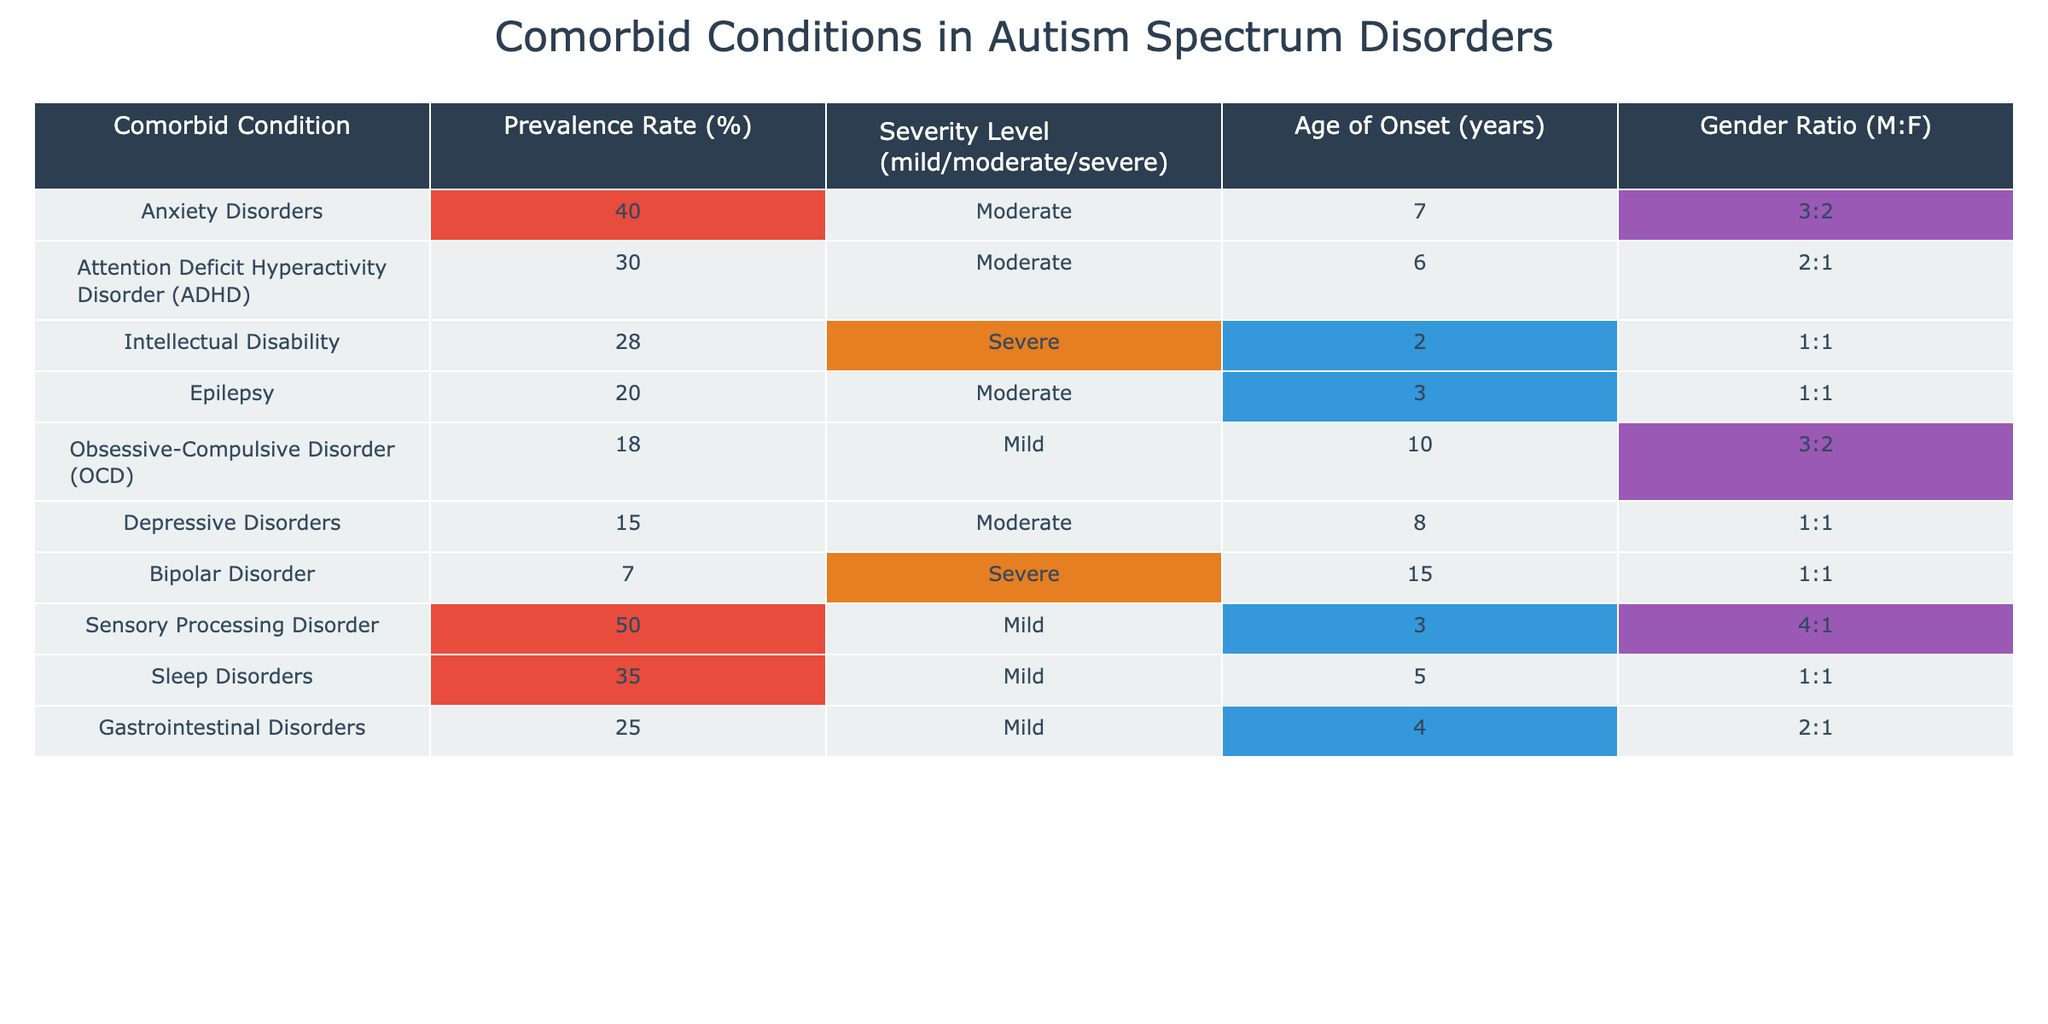What is the prevalence rate of Anxiety Disorders among individuals diagnosed with autism spectrum disorders? The table shows that the prevalence rate for Anxiety Disorders is 40%.
Answer: 40% Which comorbid condition has the highest prevalence rate? Looking at the table, Sensory Processing Disorder has a prevalence rate of 50%, which is the highest among all listed conditions.
Answer: Sensory Processing Disorder What is the age of onset for Intellectual Disability? The table states that the age of onset for Intellectual Disability is 2 years.
Answer: 2 years How many conditions listed have a severity level classified as 'Severe'? According to the table, there are 2 conditions classified as 'Severe': Intellectual Disability and Bipolar Disorder.
Answer: 2 Is the prevalence rate of Sleep Disorders higher than that of Depressive Disorders? Yes, the prevalence rate for Sleep Disorders is 35%, which is higher than the 15% for Depressive Disorders.
Answer: Yes What percentage of individuals with autism spectrum disorders experience Obsessive-Compulsive Disorder? The table indicates that the prevalence of Obsessive-Compulsive Disorder is 18%.
Answer: 18% Which gender is more likely to have Sensory Processing Disorder, based on the gender ratio? The gender ratio for Sensory Processing Disorder is 4:1, indicating that males are more likely to have this condition compared to females.
Answer: Males What is the average prevalence rate of all the conditions listed in the table? The average prevalence rate is calculated by summing the prevalence rates (40 + 30 + 28 + 20 + 18 + 15 + 7 + 50 + 35 + 25 = 298) and dividing by the number of conditions (10), yielding an average of 29.8%.
Answer: 29.8% Are most of the conditions associated with autism spectrum disorders identified as having a moderate severity level? Yes, four conditions (Anxiety Disorders, ADHD, Epilepsy, and Depressive Disorders) are classified as having a moderate severity level.
Answer: Yes Is there any comorbid condition listed that has a higher prevalence rate than Sleep Disorders but a lower severity level? Yes, Sensory Processing Disorder has a higher prevalence rate (50%) than Sleep Disorders (35%) and is classified as mild severity.
Answer: Yes 